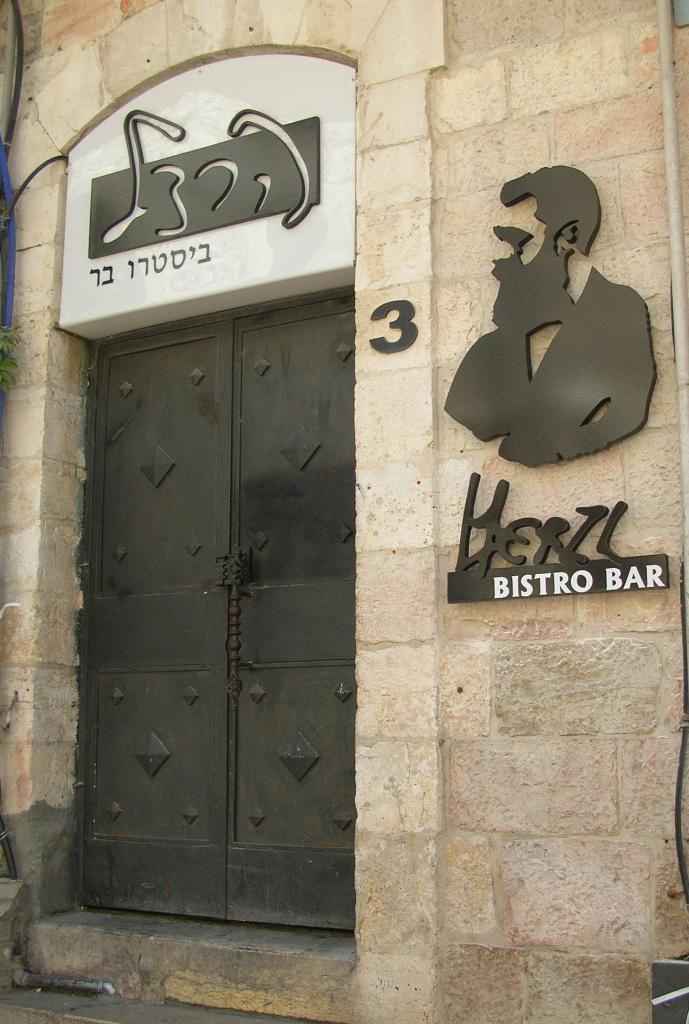What is the main structure visible in the image? There is a wall in the image. Can you describe any openings or features on the wall? Yes, there is a door at the bottom of the wall. What kind of design or image is on the wall? There is a design of a man on the right side of the wall. How many hours did the man on the wall sleep last night? There is no information about the man's sleeping habits in the image, as it only shows a design of a man on the wall. 